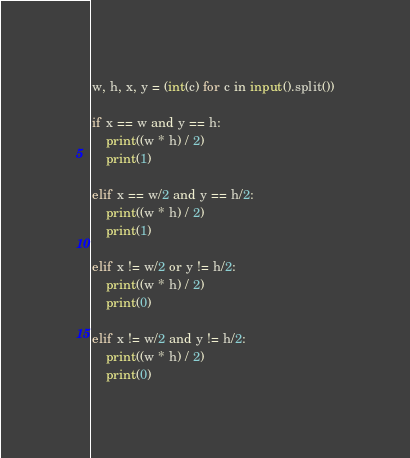<code> <loc_0><loc_0><loc_500><loc_500><_Python_>w, h, x, y = (int(c) for c in input().split())

if x == w and y == h:
    print((w * h) / 2)
    print(1)

elif x == w/2 and y == h/2:
    print((w * h) / 2)
    print(1)

elif x != w/2 or y != h/2:
    print((w * h) / 2)
    print(0)

elif x != w/2 and y != h/2:
    print((w * h) / 2)
    print(0)</code> 